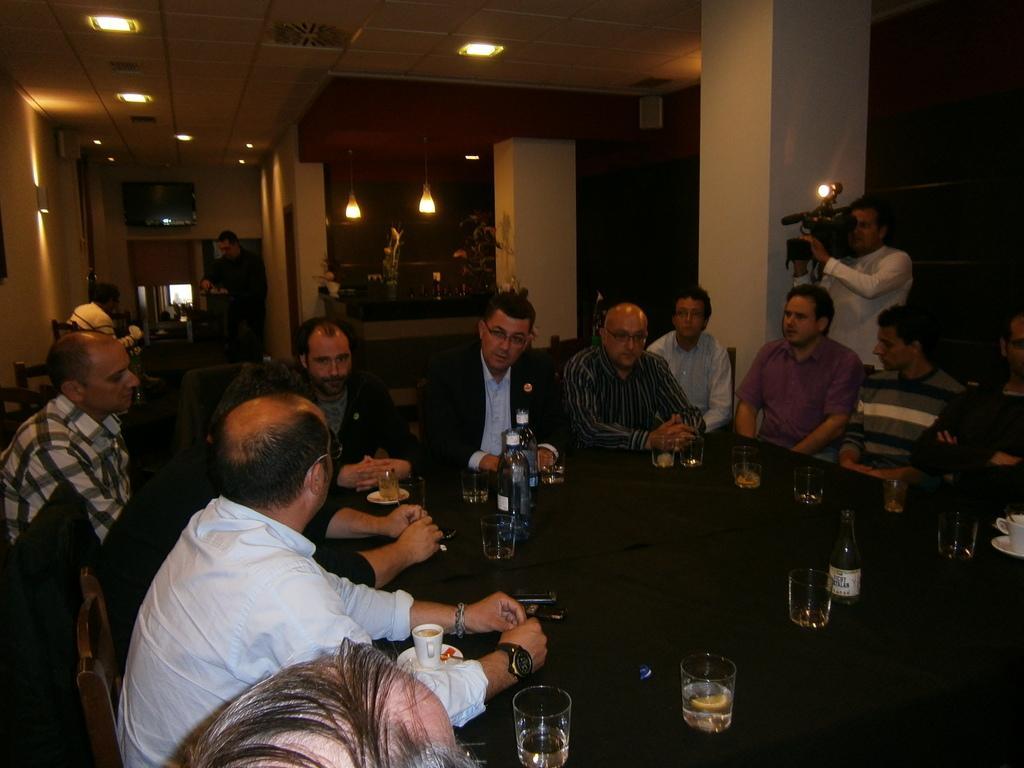How would you summarize this image in a sentence or two? In this picture there are group of people those who are sitting around the table on the chairs and there are lumps above the area of the image and there is a television at the left side of the image and there is a person who is standing at the right side of the image he is taking the video and there are bottles of juice and glasses on the table. 